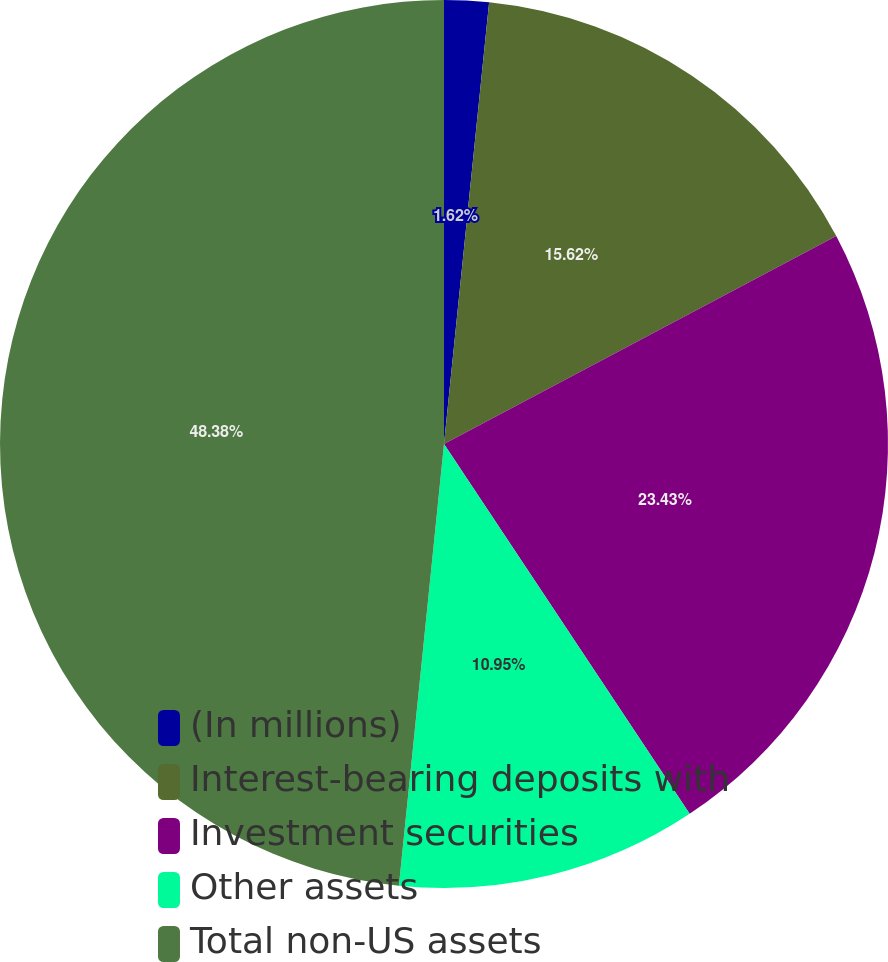Convert chart to OTSL. <chart><loc_0><loc_0><loc_500><loc_500><pie_chart><fcel>(In millions)<fcel>Interest-bearing deposits with<fcel>Investment securities<fcel>Other assets<fcel>Total non-US assets<nl><fcel>1.62%<fcel>15.62%<fcel>23.43%<fcel>10.95%<fcel>48.38%<nl></chart> 